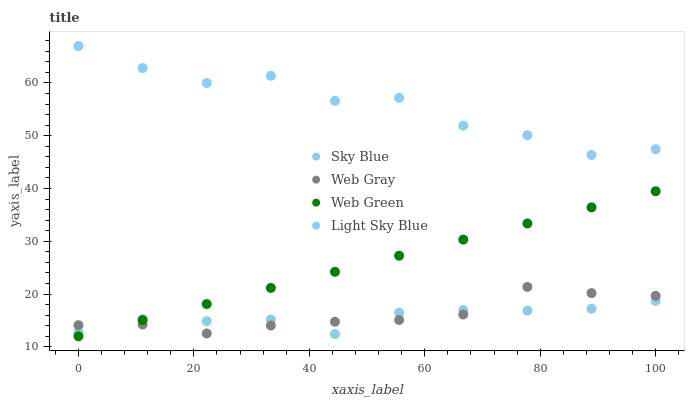Does Sky Blue have the minimum area under the curve?
Answer yes or no. Yes. Does Light Sky Blue have the maximum area under the curve?
Answer yes or no. Yes. Does Web Gray have the minimum area under the curve?
Answer yes or no. No. Does Web Gray have the maximum area under the curve?
Answer yes or no. No. Is Web Green the smoothest?
Answer yes or no. Yes. Is Light Sky Blue the roughest?
Answer yes or no. Yes. Is Web Gray the smoothest?
Answer yes or no. No. Is Web Gray the roughest?
Answer yes or no. No. Does Web Green have the lowest value?
Answer yes or no. Yes. Does Web Gray have the lowest value?
Answer yes or no. No. Does Light Sky Blue have the highest value?
Answer yes or no. Yes. Does Web Gray have the highest value?
Answer yes or no. No. Is Sky Blue less than Light Sky Blue?
Answer yes or no. Yes. Is Light Sky Blue greater than Web Gray?
Answer yes or no. Yes. Does Web Green intersect Web Gray?
Answer yes or no. Yes. Is Web Green less than Web Gray?
Answer yes or no. No. Is Web Green greater than Web Gray?
Answer yes or no. No. Does Sky Blue intersect Light Sky Blue?
Answer yes or no. No. 